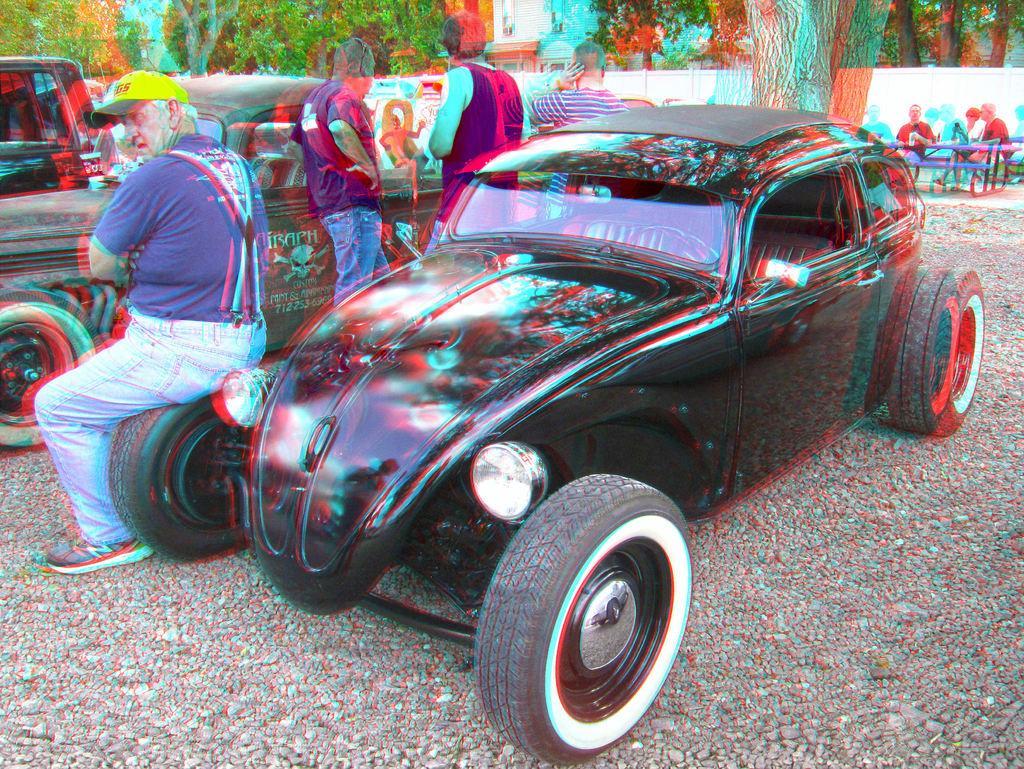In one or two sentences, can you explain what this image depicts? In this picture I can see there is a man sitting on the tire of a car and the car is in black color. In the backdrop I can see there are a group of people and there are trees and there are few buildings. 